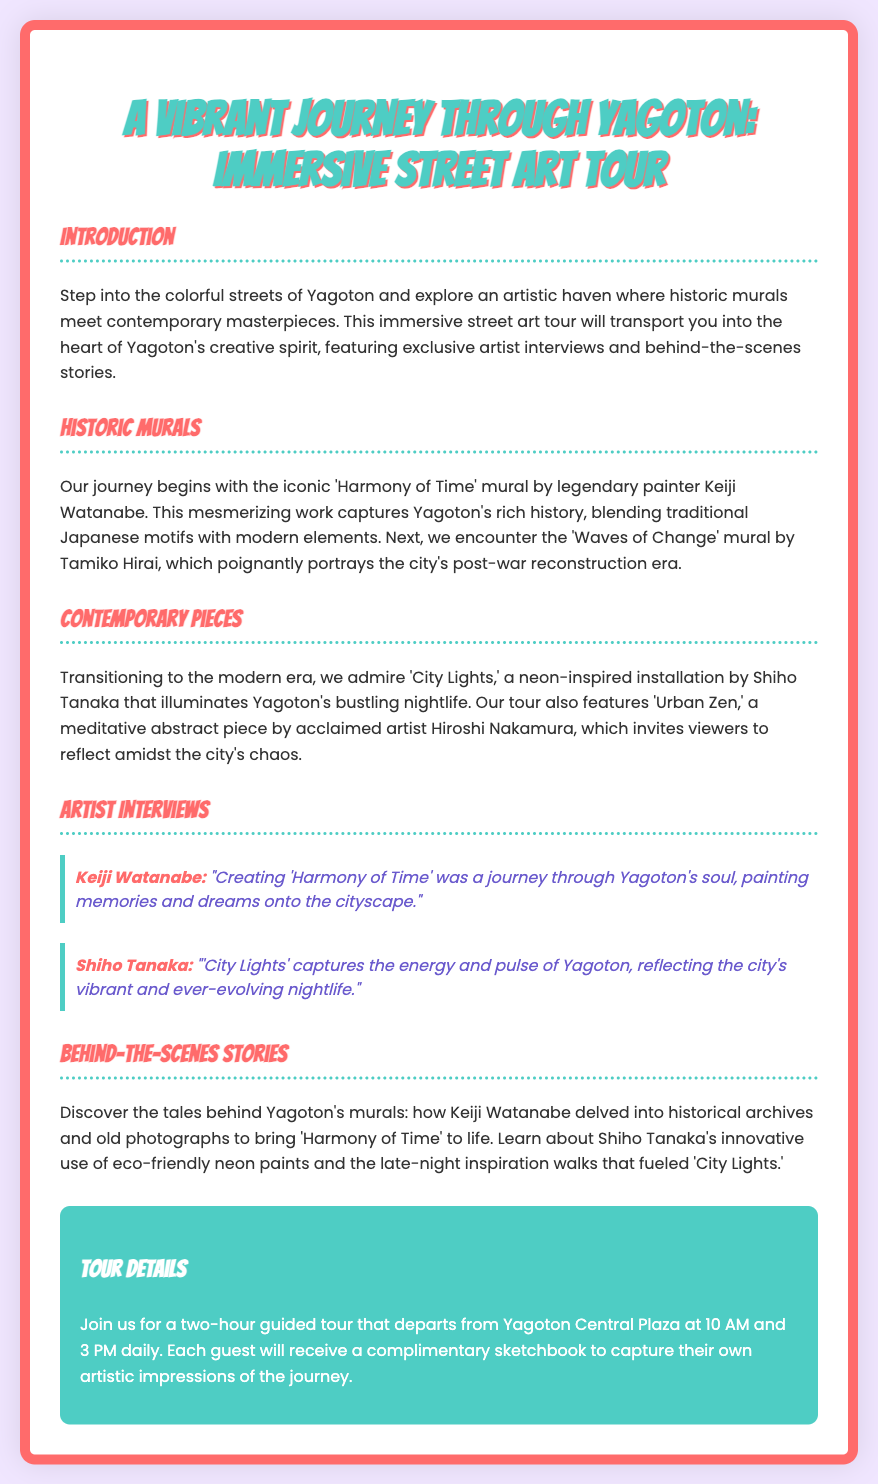what is the name of the mural by Keiji Watanabe? The mural by Keiji Watanabe is titled "Harmony of Time."
Answer: Harmony of Time who is the artist of the mural "Waves of Change"? The artist of the mural "Waves of Change" is Tamiko Hirai.
Answer: Tamiko Hirai what time does the tour depart from Yagoton Central Plaza? The tour departs from Yagoton Central Plaza at 10 AM and 3 PM.
Answer: 10 AM and 3 PM how long is the guided tour? The guided tour lasts for two hours.
Answer: two hours what type of paints did Shiho Tanaka use for "City Lights"? Shiho Tanaka used eco-friendly neon paints for "City Lights."
Answer: eco-friendly neon paints what is the color scheme of the playbill's background? The background color of the playbill is a light lavender tone.
Answer: light lavender which street art piece invites viewers to reflect? The piece that invites viewers to reflect is "Urban Zen."
Answer: Urban Zen what do guests receive to capture impressions during the tour? Guests receive a complimentary sketchbook during the tour.
Answer: complimentary sketchbook 